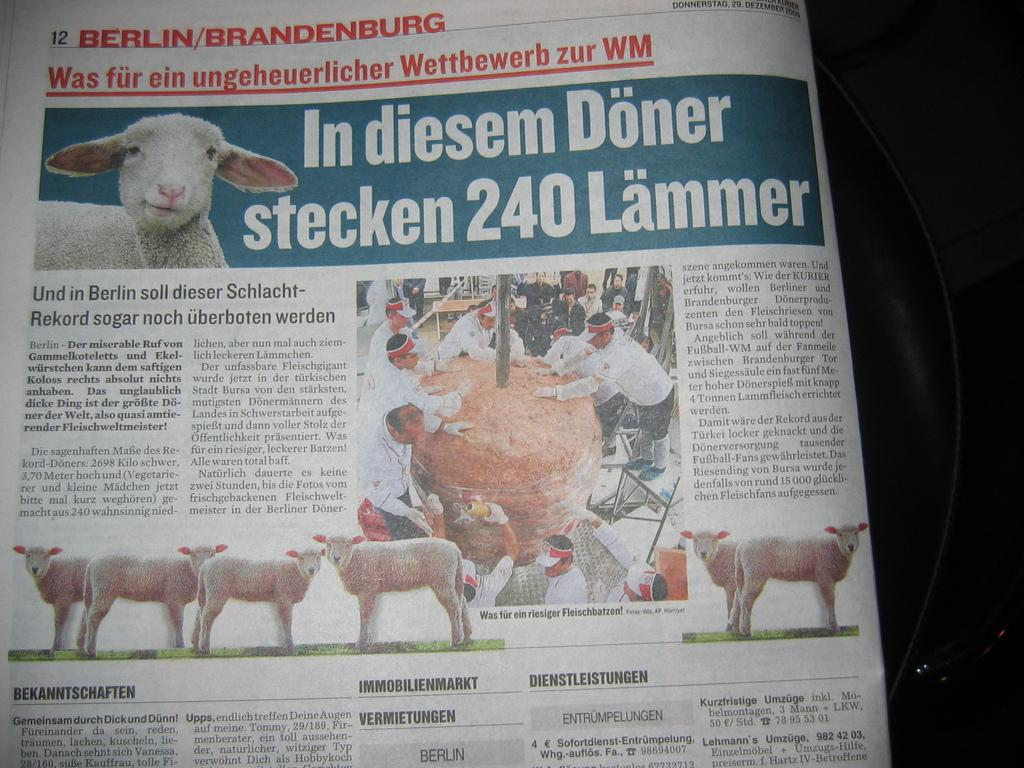What is present on the paper in the image? There is text and pictures on the paper in the image. Can you describe the content of the pictures on the paper? The pictures on the paper include sheep and people. What type of river can be seen flowing through the marble in the image? There is no river or marble present in the image; it only features a paper with text and pictures of sheep and people. 